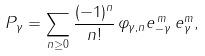Convert formula to latex. <formula><loc_0><loc_0><loc_500><loc_500>P _ { \gamma } = \sum _ { n \geq 0 } \frac { ( - 1 ) ^ { n } } { n ! } \, \varphi _ { \gamma , n } e _ { - \gamma } ^ { \, m } \, e _ { \gamma } ^ { m } ,</formula> 